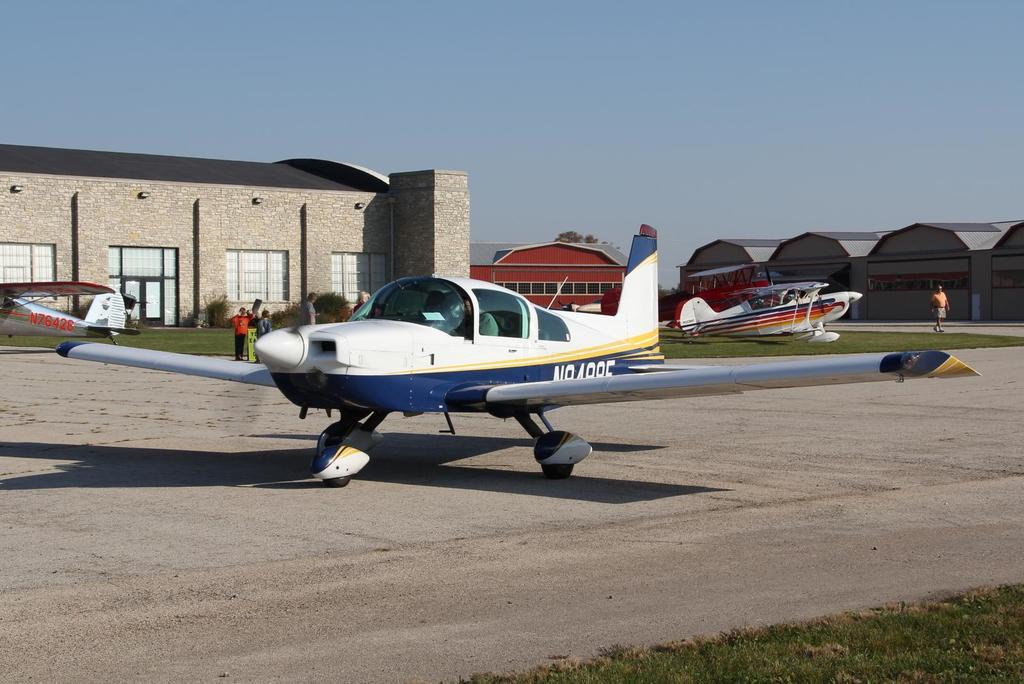<image>
Create a compact narrative representing the image presented. Small Charter Plane that says N84885 on the side of the plane, just in back of the wings. 